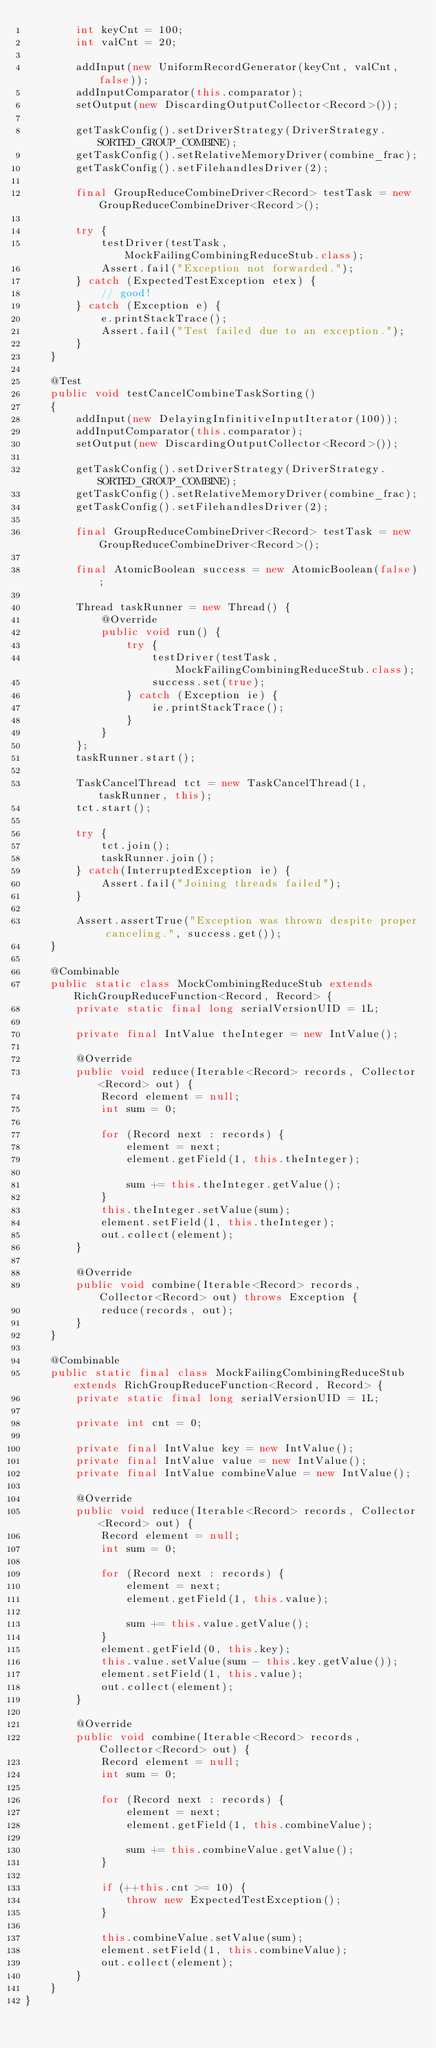Convert code to text. <code><loc_0><loc_0><loc_500><loc_500><_Java_>		int keyCnt = 100;
		int valCnt = 20;
		
		addInput(new UniformRecordGenerator(keyCnt, valCnt, false));
		addInputComparator(this.comparator);
		setOutput(new DiscardingOutputCollector<Record>());
		
		getTaskConfig().setDriverStrategy(DriverStrategy.SORTED_GROUP_COMBINE);
		getTaskConfig().setRelativeMemoryDriver(combine_frac);
		getTaskConfig().setFilehandlesDriver(2);
		
		final GroupReduceCombineDriver<Record> testTask = new GroupReduceCombineDriver<Record>();
		
		try {
			testDriver(testTask, MockFailingCombiningReduceStub.class);
			Assert.fail("Exception not forwarded.");
		} catch (ExpectedTestException etex) {
			// good!
		} catch (Exception e) {
			e.printStackTrace();
			Assert.fail("Test failed due to an exception.");
		}
	}
	
	@Test
	public void testCancelCombineTaskSorting()
	{
		addInput(new DelayingInfinitiveInputIterator(100));
		addInputComparator(this.comparator);
		setOutput(new DiscardingOutputCollector<Record>());
		
		getTaskConfig().setDriverStrategy(DriverStrategy.SORTED_GROUP_COMBINE);
		getTaskConfig().setRelativeMemoryDriver(combine_frac);
		getTaskConfig().setFilehandlesDriver(2);
		
		final GroupReduceCombineDriver<Record> testTask = new GroupReduceCombineDriver<Record>();
		
		final AtomicBoolean success = new AtomicBoolean(false);
		
		Thread taskRunner = new Thread() {
			@Override
			public void run() {
				try {
					testDriver(testTask, MockFailingCombiningReduceStub.class);
					success.set(true);
				} catch (Exception ie) {
					ie.printStackTrace();
				}
			}
		};
		taskRunner.start();
		
		TaskCancelThread tct = new TaskCancelThread(1, taskRunner, this);
		tct.start();
		
		try {
			tct.join();
			taskRunner.join();		
		} catch(InterruptedException ie) {
			Assert.fail("Joining threads failed");
		}
		
		Assert.assertTrue("Exception was thrown despite proper canceling.", success.get());
	}
	
	@Combinable
	public static class MockCombiningReduceStub extends RichGroupReduceFunction<Record, Record> {
		private static final long serialVersionUID = 1L;
		
		private final IntValue theInteger = new IntValue();

		@Override
		public void reduce(Iterable<Record> records, Collector<Record> out) {
			Record element = null;
			int sum = 0;
			
			for (Record next : records) {
				element = next;
				element.getField(1, this.theInteger);
				
				sum += this.theInteger.getValue();
			}
			this.theInteger.setValue(sum);
			element.setField(1, this.theInteger);
			out.collect(element);
		}
		
		@Override
		public void combine(Iterable<Record> records, Collector<Record> out) throws Exception {
			reduce(records, out);
		}
	}
	
	@Combinable
	public static final class MockFailingCombiningReduceStub extends RichGroupReduceFunction<Record, Record> {
		private static final long serialVersionUID = 1L;
		
		private int cnt = 0;
		
		private final IntValue key = new IntValue();
		private final IntValue value = new IntValue();
		private final IntValue combineValue = new IntValue();

		@Override
		public void reduce(Iterable<Record> records, Collector<Record> out) {
			Record element = null;
			int sum = 0;
			
			for (Record next : records) {
				element = next;
				element.getField(1, this.value);
				
				sum += this.value.getValue();
			}
			element.getField(0, this.key);
			this.value.setValue(sum - this.key.getValue());
			element.setField(1, this.value);
			out.collect(element);
		}
		
		@Override
		public void combine(Iterable<Record> records, Collector<Record> out) {
			Record element = null;
			int sum = 0;
			
			for (Record next : records) {
				element = next;
				element.getField(1, this.combineValue);
				
				sum += this.combineValue.getValue();
			}
			
			if (++this.cnt >= 10) {
				throw new ExpectedTestException();
			}
			
			this.combineValue.setValue(sum);
			element.setField(1, this.combineValue);
			out.collect(element);
		}
	}
}
</code> 